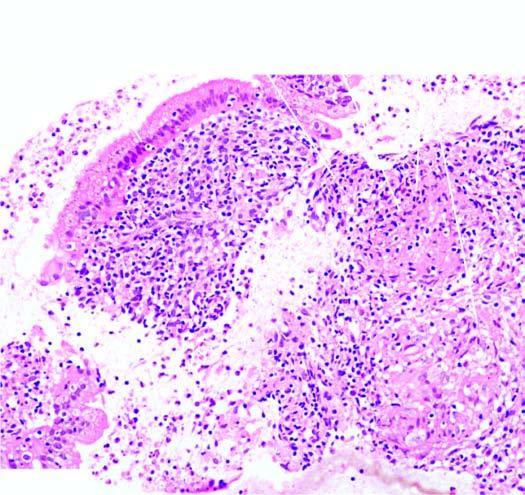has the mucosal caseating epithelioid cell granulomas having langhans 'giant cells and peripheral layer of lymphocytes?
Answer the question using a single word or phrase. No 